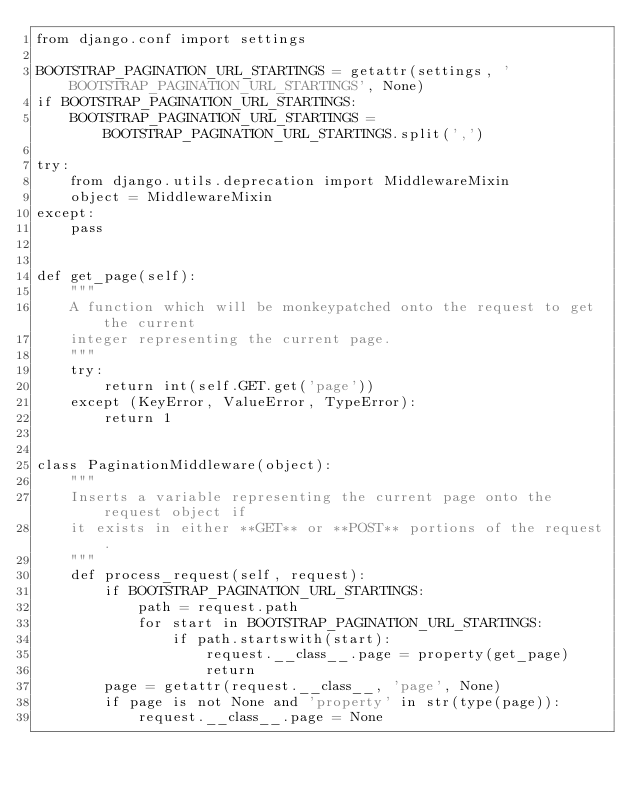<code> <loc_0><loc_0><loc_500><loc_500><_Python_>from django.conf import settings

BOOTSTRAP_PAGINATION_URL_STARTINGS = getattr(settings, 'BOOTSTRAP_PAGINATION_URL_STARTINGS', None)
if BOOTSTRAP_PAGINATION_URL_STARTINGS:
    BOOTSTRAP_PAGINATION_URL_STARTINGS = BOOTSTRAP_PAGINATION_URL_STARTINGS.split(',')

try:
    from django.utils.deprecation import MiddlewareMixin
    object = MiddlewareMixin
except:
    pass


def get_page(self):
    """
    A function which will be monkeypatched onto the request to get the current
    integer representing the current page.
    """
    try:
        return int(self.GET.get('page'))
    except (KeyError, ValueError, TypeError):
        return 1


class PaginationMiddleware(object):
    """
    Inserts a variable representing the current page onto the request object if
    it exists in either **GET** or **POST** portions of the request.
    """
    def process_request(self, request):
        if BOOTSTRAP_PAGINATION_URL_STARTINGS:
            path = request.path
            for start in BOOTSTRAP_PAGINATION_URL_STARTINGS:
                if path.startswith(start):
                    request.__class__.page = property(get_page)
                    return
        page = getattr(request.__class__, 'page', None)
        if page is not None and 'property' in str(type(page)):
            request.__class__.page = None

</code> 